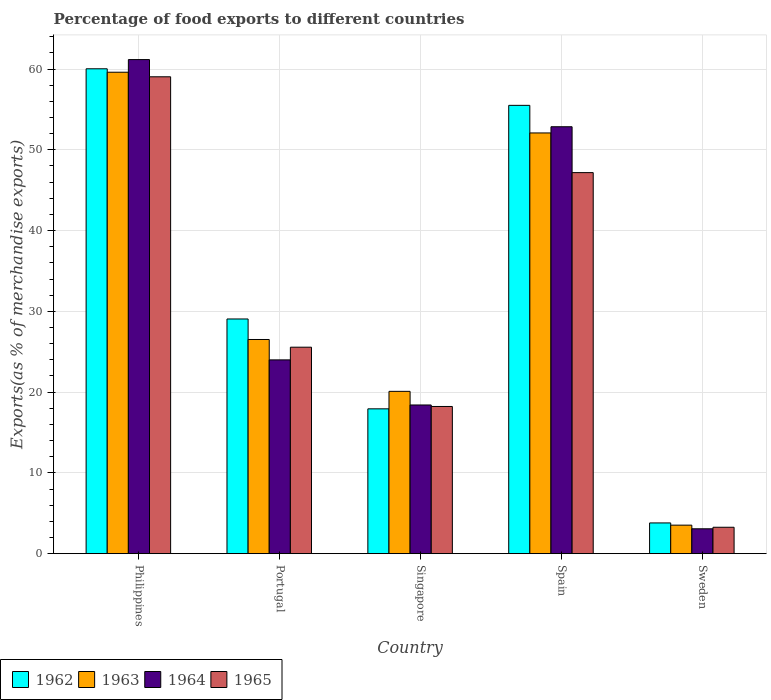Are the number of bars per tick equal to the number of legend labels?
Provide a short and direct response. Yes. How many bars are there on the 5th tick from the left?
Offer a terse response. 4. How many bars are there on the 3rd tick from the right?
Make the answer very short. 4. What is the label of the 4th group of bars from the left?
Give a very brief answer. Spain. In how many cases, is the number of bars for a given country not equal to the number of legend labels?
Make the answer very short. 0. What is the percentage of exports to different countries in 1962 in Sweden?
Your answer should be compact. 3.8. Across all countries, what is the maximum percentage of exports to different countries in 1964?
Make the answer very short. 61.17. Across all countries, what is the minimum percentage of exports to different countries in 1965?
Your answer should be compact. 3.27. What is the total percentage of exports to different countries in 1963 in the graph?
Give a very brief answer. 161.82. What is the difference between the percentage of exports to different countries in 1964 in Spain and that in Sweden?
Make the answer very short. 49.77. What is the difference between the percentage of exports to different countries in 1962 in Singapore and the percentage of exports to different countries in 1963 in Portugal?
Your answer should be very brief. -8.58. What is the average percentage of exports to different countries in 1964 per country?
Ensure brevity in your answer.  31.9. What is the difference between the percentage of exports to different countries of/in 1962 and percentage of exports to different countries of/in 1965 in Singapore?
Make the answer very short. -0.29. In how many countries, is the percentage of exports to different countries in 1964 greater than 34 %?
Ensure brevity in your answer.  2. What is the ratio of the percentage of exports to different countries in 1963 in Philippines to that in Singapore?
Your answer should be very brief. 2.97. Is the percentage of exports to different countries in 1965 in Philippines less than that in Singapore?
Ensure brevity in your answer.  No. Is the difference between the percentage of exports to different countries in 1962 in Singapore and Spain greater than the difference between the percentage of exports to different countries in 1965 in Singapore and Spain?
Offer a terse response. No. What is the difference between the highest and the second highest percentage of exports to different countries in 1963?
Offer a terse response. -33.09. What is the difference between the highest and the lowest percentage of exports to different countries in 1965?
Ensure brevity in your answer.  55.77. What does the 3rd bar from the left in Philippines represents?
Offer a terse response. 1964. What does the 2nd bar from the right in Sweden represents?
Keep it short and to the point. 1964. Is it the case that in every country, the sum of the percentage of exports to different countries in 1964 and percentage of exports to different countries in 1962 is greater than the percentage of exports to different countries in 1965?
Make the answer very short. Yes. How many bars are there?
Ensure brevity in your answer.  20. Are all the bars in the graph horizontal?
Give a very brief answer. No. How many countries are there in the graph?
Your response must be concise. 5. What is the difference between two consecutive major ticks on the Y-axis?
Give a very brief answer. 10. Does the graph contain any zero values?
Offer a very short reply. No. Does the graph contain grids?
Provide a succinct answer. Yes. What is the title of the graph?
Your answer should be very brief. Percentage of food exports to different countries. Does "1981" appear as one of the legend labels in the graph?
Make the answer very short. No. What is the label or title of the X-axis?
Your response must be concise. Country. What is the label or title of the Y-axis?
Ensure brevity in your answer.  Exports(as % of merchandise exports). What is the Exports(as % of merchandise exports) of 1962 in Philippines?
Ensure brevity in your answer.  60.03. What is the Exports(as % of merchandise exports) of 1963 in Philippines?
Your response must be concise. 59.6. What is the Exports(as % of merchandise exports) of 1964 in Philippines?
Keep it short and to the point. 61.17. What is the Exports(as % of merchandise exports) in 1965 in Philippines?
Provide a succinct answer. 59.04. What is the Exports(as % of merchandise exports) in 1962 in Portugal?
Give a very brief answer. 29.05. What is the Exports(as % of merchandise exports) in 1963 in Portugal?
Offer a very short reply. 26.51. What is the Exports(as % of merchandise exports) of 1964 in Portugal?
Provide a short and direct response. 23.99. What is the Exports(as % of merchandise exports) in 1965 in Portugal?
Your answer should be very brief. 25.56. What is the Exports(as % of merchandise exports) of 1962 in Singapore?
Your response must be concise. 17.93. What is the Exports(as % of merchandise exports) in 1963 in Singapore?
Make the answer very short. 20.09. What is the Exports(as % of merchandise exports) in 1964 in Singapore?
Offer a terse response. 18.41. What is the Exports(as % of merchandise exports) of 1965 in Singapore?
Offer a terse response. 18.22. What is the Exports(as % of merchandise exports) in 1962 in Spain?
Your response must be concise. 55.5. What is the Exports(as % of merchandise exports) of 1963 in Spain?
Your answer should be compact. 52.09. What is the Exports(as % of merchandise exports) of 1964 in Spain?
Provide a succinct answer. 52.85. What is the Exports(as % of merchandise exports) of 1965 in Spain?
Provide a short and direct response. 47.17. What is the Exports(as % of merchandise exports) of 1962 in Sweden?
Keep it short and to the point. 3.8. What is the Exports(as % of merchandise exports) in 1963 in Sweden?
Offer a terse response. 3.53. What is the Exports(as % of merchandise exports) in 1964 in Sweden?
Your answer should be very brief. 3.08. What is the Exports(as % of merchandise exports) of 1965 in Sweden?
Keep it short and to the point. 3.27. Across all countries, what is the maximum Exports(as % of merchandise exports) in 1962?
Your answer should be compact. 60.03. Across all countries, what is the maximum Exports(as % of merchandise exports) of 1963?
Offer a terse response. 59.6. Across all countries, what is the maximum Exports(as % of merchandise exports) of 1964?
Your answer should be compact. 61.17. Across all countries, what is the maximum Exports(as % of merchandise exports) in 1965?
Make the answer very short. 59.04. Across all countries, what is the minimum Exports(as % of merchandise exports) of 1962?
Provide a succinct answer. 3.8. Across all countries, what is the minimum Exports(as % of merchandise exports) of 1963?
Give a very brief answer. 3.53. Across all countries, what is the minimum Exports(as % of merchandise exports) of 1964?
Give a very brief answer. 3.08. Across all countries, what is the minimum Exports(as % of merchandise exports) of 1965?
Offer a terse response. 3.27. What is the total Exports(as % of merchandise exports) in 1962 in the graph?
Offer a very short reply. 166.32. What is the total Exports(as % of merchandise exports) of 1963 in the graph?
Give a very brief answer. 161.82. What is the total Exports(as % of merchandise exports) of 1964 in the graph?
Offer a very short reply. 159.49. What is the total Exports(as % of merchandise exports) of 1965 in the graph?
Your answer should be very brief. 153.26. What is the difference between the Exports(as % of merchandise exports) of 1962 in Philippines and that in Portugal?
Give a very brief answer. 30.97. What is the difference between the Exports(as % of merchandise exports) in 1963 in Philippines and that in Portugal?
Provide a succinct answer. 33.09. What is the difference between the Exports(as % of merchandise exports) in 1964 in Philippines and that in Portugal?
Your answer should be compact. 37.18. What is the difference between the Exports(as % of merchandise exports) in 1965 in Philippines and that in Portugal?
Make the answer very short. 33.48. What is the difference between the Exports(as % of merchandise exports) in 1962 in Philippines and that in Singapore?
Give a very brief answer. 42.1. What is the difference between the Exports(as % of merchandise exports) in 1963 in Philippines and that in Singapore?
Your answer should be very brief. 39.51. What is the difference between the Exports(as % of merchandise exports) in 1964 in Philippines and that in Singapore?
Your answer should be compact. 42.76. What is the difference between the Exports(as % of merchandise exports) of 1965 in Philippines and that in Singapore?
Provide a succinct answer. 40.81. What is the difference between the Exports(as % of merchandise exports) of 1962 in Philippines and that in Spain?
Give a very brief answer. 4.53. What is the difference between the Exports(as % of merchandise exports) of 1963 in Philippines and that in Spain?
Your answer should be very brief. 7.52. What is the difference between the Exports(as % of merchandise exports) in 1964 in Philippines and that in Spain?
Offer a terse response. 8.31. What is the difference between the Exports(as % of merchandise exports) in 1965 in Philippines and that in Spain?
Ensure brevity in your answer.  11.86. What is the difference between the Exports(as % of merchandise exports) in 1962 in Philippines and that in Sweden?
Offer a very short reply. 56.22. What is the difference between the Exports(as % of merchandise exports) of 1963 in Philippines and that in Sweden?
Offer a terse response. 56.07. What is the difference between the Exports(as % of merchandise exports) in 1964 in Philippines and that in Sweden?
Provide a short and direct response. 58.09. What is the difference between the Exports(as % of merchandise exports) in 1965 in Philippines and that in Sweden?
Offer a very short reply. 55.77. What is the difference between the Exports(as % of merchandise exports) in 1962 in Portugal and that in Singapore?
Give a very brief answer. 11.12. What is the difference between the Exports(as % of merchandise exports) of 1963 in Portugal and that in Singapore?
Make the answer very short. 6.42. What is the difference between the Exports(as % of merchandise exports) of 1964 in Portugal and that in Singapore?
Your answer should be very brief. 5.58. What is the difference between the Exports(as % of merchandise exports) of 1965 in Portugal and that in Singapore?
Ensure brevity in your answer.  7.34. What is the difference between the Exports(as % of merchandise exports) in 1962 in Portugal and that in Spain?
Your answer should be very brief. -26.45. What is the difference between the Exports(as % of merchandise exports) of 1963 in Portugal and that in Spain?
Your answer should be compact. -25.57. What is the difference between the Exports(as % of merchandise exports) of 1964 in Portugal and that in Spain?
Your response must be concise. -28.86. What is the difference between the Exports(as % of merchandise exports) in 1965 in Portugal and that in Spain?
Keep it short and to the point. -21.61. What is the difference between the Exports(as % of merchandise exports) of 1962 in Portugal and that in Sweden?
Ensure brevity in your answer.  25.25. What is the difference between the Exports(as % of merchandise exports) of 1963 in Portugal and that in Sweden?
Provide a succinct answer. 22.98. What is the difference between the Exports(as % of merchandise exports) of 1964 in Portugal and that in Sweden?
Provide a succinct answer. 20.91. What is the difference between the Exports(as % of merchandise exports) in 1965 in Portugal and that in Sweden?
Provide a short and direct response. 22.29. What is the difference between the Exports(as % of merchandise exports) of 1962 in Singapore and that in Spain?
Ensure brevity in your answer.  -37.57. What is the difference between the Exports(as % of merchandise exports) in 1963 in Singapore and that in Spain?
Your answer should be very brief. -31.99. What is the difference between the Exports(as % of merchandise exports) in 1964 in Singapore and that in Spain?
Provide a short and direct response. -34.45. What is the difference between the Exports(as % of merchandise exports) of 1965 in Singapore and that in Spain?
Your answer should be compact. -28.95. What is the difference between the Exports(as % of merchandise exports) of 1962 in Singapore and that in Sweden?
Provide a succinct answer. 14.13. What is the difference between the Exports(as % of merchandise exports) of 1963 in Singapore and that in Sweden?
Provide a succinct answer. 16.56. What is the difference between the Exports(as % of merchandise exports) of 1964 in Singapore and that in Sweden?
Your answer should be compact. 15.33. What is the difference between the Exports(as % of merchandise exports) in 1965 in Singapore and that in Sweden?
Your response must be concise. 14.95. What is the difference between the Exports(as % of merchandise exports) of 1962 in Spain and that in Sweden?
Ensure brevity in your answer.  51.7. What is the difference between the Exports(as % of merchandise exports) in 1963 in Spain and that in Sweden?
Offer a very short reply. 48.56. What is the difference between the Exports(as % of merchandise exports) in 1964 in Spain and that in Sweden?
Keep it short and to the point. 49.77. What is the difference between the Exports(as % of merchandise exports) in 1965 in Spain and that in Sweden?
Your response must be concise. 43.9. What is the difference between the Exports(as % of merchandise exports) in 1962 in Philippines and the Exports(as % of merchandise exports) in 1963 in Portugal?
Your answer should be very brief. 33.51. What is the difference between the Exports(as % of merchandise exports) in 1962 in Philippines and the Exports(as % of merchandise exports) in 1964 in Portugal?
Offer a terse response. 36.04. What is the difference between the Exports(as % of merchandise exports) in 1962 in Philippines and the Exports(as % of merchandise exports) in 1965 in Portugal?
Ensure brevity in your answer.  34.47. What is the difference between the Exports(as % of merchandise exports) of 1963 in Philippines and the Exports(as % of merchandise exports) of 1964 in Portugal?
Your answer should be compact. 35.61. What is the difference between the Exports(as % of merchandise exports) of 1963 in Philippines and the Exports(as % of merchandise exports) of 1965 in Portugal?
Make the answer very short. 34.04. What is the difference between the Exports(as % of merchandise exports) in 1964 in Philippines and the Exports(as % of merchandise exports) in 1965 in Portugal?
Give a very brief answer. 35.61. What is the difference between the Exports(as % of merchandise exports) in 1962 in Philippines and the Exports(as % of merchandise exports) in 1963 in Singapore?
Your answer should be very brief. 39.93. What is the difference between the Exports(as % of merchandise exports) in 1962 in Philippines and the Exports(as % of merchandise exports) in 1964 in Singapore?
Provide a short and direct response. 41.62. What is the difference between the Exports(as % of merchandise exports) of 1962 in Philippines and the Exports(as % of merchandise exports) of 1965 in Singapore?
Your answer should be very brief. 41.8. What is the difference between the Exports(as % of merchandise exports) in 1963 in Philippines and the Exports(as % of merchandise exports) in 1964 in Singapore?
Your answer should be very brief. 41.2. What is the difference between the Exports(as % of merchandise exports) of 1963 in Philippines and the Exports(as % of merchandise exports) of 1965 in Singapore?
Ensure brevity in your answer.  41.38. What is the difference between the Exports(as % of merchandise exports) in 1964 in Philippines and the Exports(as % of merchandise exports) in 1965 in Singapore?
Provide a succinct answer. 42.95. What is the difference between the Exports(as % of merchandise exports) in 1962 in Philippines and the Exports(as % of merchandise exports) in 1963 in Spain?
Ensure brevity in your answer.  7.94. What is the difference between the Exports(as % of merchandise exports) of 1962 in Philippines and the Exports(as % of merchandise exports) of 1964 in Spain?
Provide a succinct answer. 7.17. What is the difference between the Exports(as % of merchandise exports) in 1962 in Philippines and the Exports(as % of merchandise exports) in 1965 in Spain?
Keep it short and to the point. 12.85. What is the difference between the Exports(as % of merchandise exports) of 1963 in Philippines and the Exports(as % of merchandise exports) of 1964 in Spain?
Make the answer very short. 6.75. What is the difference between the Exports(as % of merchandise exports) of 1963 in Philippines and the Exports(as % of merchandise exports) of 1965 in Spain?
Provide a short and direct response. 12.43. What is the difference between the Exports(as % of merchandise exports) of 1964 in Philippines and the Exports(as % of merchandise exports) of 1965 in Spain?
Keep it short and to the point. 13.99. What is the difference between the Exports(as % of merchandise exports) in 1962 in Philippines and the Exports(as % of merchandise exports) in 1963 in Sweden?
Your answer should be compact. 56.5. What is the difference between the Exports(as % of merchandise exports) in 1962 in Philippines and the Exports(as % of merchandise exports) in 1964 in Sweden?
Offer a very short reply. 56.95. What is the difference between the Exports(as % of merchandise exports) in 1962 in Philippines and the Exports(as % of merchandise exports) in 1965 in Sweden?
Provide a short and direct response. 56.76. What is the difference between the Exports(as % of merchandise exports) of 1963 in Philippines and the Exports(as % of merchandise exports) of 1964 in Sweden?
Offer a very short reply. 56.52. What is the difference between the Exports(as % of merchandise exports) of 1963 in Philippines and the Exports(as % of merchandise exports) of 1965 in Sweden?
Offer a very short reply. 56.33. What is the difference between the Exports(as % of merchandise exports) in 1964 in Philippines and the Exports(as % of merchandise exports) in 1965 in Sweden?
Your response must be concise. 57.9. What is the difference between the Exports(as % of merchandise exports) of 1962 in Portugal and the Exports(as % of merchandise exports) of 1963 in Singapore?
Offer a terse response. 8.96. What is the difference between the Exports(as % of merchandise exports) in 1962 in Portugal and the Exports(as % of merchandise exports) in 1964 in Singapore?
Give a very brief answer. 10.65. What is the difference between the Exports(as % of merchandise exports) in 1962 in Portugal and the Exports(as % of merchandise exports) in 1965 in Singapore?
Your answer should be very brief. 10.83. What is the difference between the Exports(as % of merchandise exports) in 1963 in Portugal and the Exports(as % of merchandise exports) in 1964 in Singapore?
Your response must be concise. 8.11. What is the difference between the Exports(as % of merchandise exports) of 1963 in Portugal and the Exports(as % of merchandise exports) of 1965 in Singapore?
Offer a very short reply. 8.29. What is the difference between the Exports(as % of merchandise exports) in 1964 in Portugal and the Exports(as % of merchandise exports) in 1965 in Singapore?
Ensure brevity in your answer.  5.77. What is the difference between the Exports(as % of merchandise exports) of 1962 in Portugal and the Exports(as % of merchandise exports) of 1963 in Spain?
Keep it short and to the point. -23.03. What is the difference between the Exports(as % of merchandise exports) of 1962 in Portugal and the Exports(as % of merchandise exports) of 1964 in Spain?
Provide a short and direct response. -23.8. What is the difference between the Exports(as % of merchandise exports) in 1962 in Portugal and the Exports(as % of merchandise exports) in 1965 in Spain?
Ensure brevity in your answer.  -18.12. What is the difference between the Exports(as % of merchandise exports) in 1963 in Portugal and the Exports(as % of merchandise exports) in 1964 in Spain?
Keep it short and to the point. -26.34. What is the difference between the Exports(as % of merchandise exports) of 1963 in Portugal and the Exports(as % of merchandise exports) of 1965 in Spain?
Give a very brief answer. -20.66. What is the difference between the Exports(as % of merchandise exports) of 1964 in Portugal and the Exports(as % of merchandise exports) of 1965 in Spain?
Offer a very short reply. -23.18. What is the difference between the Exports(as % of merchandise exports) of 1962 in Portugal and the Exports(as % of merchandise exports) of 1963 in Sweden?
Your response must be concise. 25.53. What is the difference between the Exports(as % of merchandise exports) in 1962 in Portugal and the Exports(as % of merchandise exports) in 1964 in Sweden?
Ensure brevity in your answer.  25.98. What is the difference between the Exports(as % of merchandise exports) of 1962 in Portugal and the Exports(as % of merchandise exports) of 1965 in Sweden?
Your response must be concise. 25.79. What is the difference between the Exports(as % of merchandise exports) of 1963 in Portugal and the Exports(as % of merchandise exports) of 1964 in Sweden?
Offer a terse response. 23.44. What is the difference between the Exports(as % of merchandise exports) of 1963 in Portugal and the Exports(as % of merchandise exports) of 1965 in Sweden?
Your answer should be compact. 23.25. What is the difference between the Exports(as % of merchandise exports) of 1964 in Portugal and the Exports(as % of merchandise exports) of 1965 in Sweden?
Your answer should be very brief. 20.72. What is the difference between the Exports(as % of merchandise exports) in 1962 in Singapore and the Exports(as % of merchandise exports) in 1963 in Spain?
Offer a very short reply. -34.16. What is the difference between the Exports(as % of merchandise exports) in 1962 in Singapore and the Exports(as % of merchandise exports) in 1964 in Spain?
Provide a succinct answer. -34.92. What is the difference between the Exports(as % of merchandise exports) of 1962 in Singapore and the Exports(as % of merchandise exports) of 1965 in Spain?
Keep it short and to the point. -29.24. What is the difference between the Exports(as % of merchandise exports) of 1963 in Singapore and the Exports(as % of merchandise exports) of 1964 in Spain?
Your answer should be very brief. -32.76. What is the difference between the Exports(as % of merchandise exports) in 1963 in Singapore and the Exports(as % of merchandise exports) in 1965 in Spain?
Ensure brevity in your answer.  -27.08. What is the difference between the Exports(as % of merchandise exports) in 1964 in Singapore and the Exports(as % of merchandise exports) in 1965 in Spain?
Your answer should be very brief. -28.77. What is the difference between the Exports(as % of merchandise exports) in 1962 in Singapore and the Exports(as % of merchandise exports) in 1963 in Sweden?
Your response must be concise. 14.4. What is the difference between the Exports(as % of merchandise exports) of 1962 in Singapore and the Exports(as % of merchandise exports) of 1964 in Sweden?
Make the answer very short. 14.85. What is the difference between the Exports(as % of merchandise exports) of 1962 in Singapore and the Exports(as % of merchandise exports) of 1965 in Sweden?
Your answer should be compact. 14.66. What is the difference between the Exports(as % of merchandise exports) of 1963 in Singapore and the Exports(as % of merchandise exports) of 1964 in Sweden?
Your response must be concise. 17.01. What is the difference between the Exports(as % of merchandise exports) of 1963 in Singapore and the Exports(as % of merchandise exports) of 1965 in Sweden?
Make the answer very short. 16.83. What is the difference between the Exports(as % of merchandise exports) in 1964 in Singapore and the Exports(as % of merchandise exports) in 1965 in Sweden?
Ensure brevity in your answer.  15.14. What is the difference between the Exports(as % of merchandise exports) in 1962 in Spain and the Exports(as % of merchandise exports) in 1963 in Sweden?
Ensure brevity in your answer.  51.97. What is the difference between the Exports(as % of merchandise exports) in 1962 in Spain and the Exports(as % of merchandise exports) in 1964 in Sweden?
Offer a very short reply. 52.42. What is the difference between the Exports(as % of merchandise exports) in 1962 in Spain and the Exports(as % of merchandise exports) in 1965 in Sweden?
Make the answer very short. 52.23. What is the difference between the Exports(as % of merchandise exports) in 1963 in Spain and the Exports(as % of merchandise exports) in 1964 in Sweden?
Your response must be concise. 49.01. What is the difference between the Exports(as % of merchandise exports) in 1963 in Spain and the Exports(as % of merchandise exports) in 1965 in Sweden?
Your response must be concise. 48.82. What is the difference between the Exports(as % of merchandise exports) of 1964 in Spain and the Exports(as % of merchandise exports) of 1965 in Sweden?
Ensure brevity in your answer.  49.58. What is the average Exports(as % of merchandise exports) of 1962 per country?
Ensure brevity in your answer.  33.26. What is the average Exports(as % of merchandise exports) of 1963 per country?
Make the answer very short. 32.36. What is the average Exports(as % of merchandise exports) of 1964 per country?
Offer a terse response. 31.9. What is the average Exports(as % of merchandise exports) in 1965 per country?
Provide a succinct answer. 30.65. What is the difference between the Exports(as % of merchandise exports) of 1962 and Exports(as % of merchandise exports) of 1963 in Philippines?
Keep it short and to the point. 0.42. What is the difference between the Exports(as % of merchandise exports) in 1962 and Exports(as % of merchandise exports) in 1964 in Philippines?
Your response must be concise. -1.14. What is the difference between the Exports(as % of merchandise exports) in 1962 and Exports(as % of merchandise exports) in 1965 in Philippines?
Your answer should be compact. 0.99. What is the difference between the Exports(as % of merchandise exports) in 1963 and Exports(as % of merchandise exports) in 1964 in Philippines?
Provide a succinct answer. -1.57. What is the difference between the Exports(as % of merchandise exports) in 1963 and Exports(as % of merchandise exports) in 1965 in Philippines?
Offer a terse response. 0.57. What is the difference between the Exports(as % of merchandise exports) of 1964 and Exports(as % of merchandise exports) of 1965 in Philippines?
Your answer should be compact. 2.13. What is the difference between the Exports(as % of merchandise exports) of 1962 and Exports(as % of merchandise exports) of 1963 in Portugal?
Keep it short and to the point. 2.54. What is the difference between the Exports(as % of merchandise exports) of 1962 and Exports(as % of merchandise exports) of 1964 in Portugal?
Provide a succinct answer. 5.06. What is the difference between the Exports(as % of merchandise exports) of 1962 and Exports(as % of merchandise exports) of 1965 in Portugal?
Keep it short and to the point. 3.49. What is the difference between the Exports(as % of merchandise exports) of 1963 and Exports(as % of merchandise exports) of 1964 in Portugal?
Make the answer very short. 2.52. What is the difference between the Exports(as % of merchandise exports) in 1963 and Exports(as % of merchandise exports) in 1965 in Portugal?
Offer a terse response. 0.95. What is the difference between the Exports(as % of merchandise exports) of 1964 and Exports(as % of merchandise exports) of 1965 in Portugal?
Provide a short and direct response. -1.57. What is the difference between the Exports(as % of merchandise exports) of 1962 and Exports(as % of merchandise exports) of 1963 in Singapore?
Make the answer very short. -2.16. What is the difference between the Exports(as % of merchandise exports) of 1962 and Exports(as % of merchandise exports) of 1964 in Singapore?
Give a very brief answer. -0.48. What is the difference between the Exports(as % of merchandise exports) of 1962 and Exports(as % of merchandise exports) of 1965 in Singapore?
Offer a very short reply. -0.29. What is the difference between the Exports(as % of merchandise exports) in 1963 and Exports(as % of merchandise exports) in 1964 in Singapore?
Ensure brevity in your answer.  1.69. What is the difference between the Exports(as % of merchandise exports) of 1963 and Exports(as % of merchandise exports) of 1965 in Singapore?
Your answer should be compact. 1.87. What is the difference between the Exports(as % of merchandise exports) in 1964 and Exports(as % of merchandise exports) in 1965 in Singapore?
Provide a short and direct response. 0.18. What is the difference between the Exports(as % of merchandise exports) of 1962 and Exports(as % of merchandise exports) of 1963 in Spain?
Your answer should be very brief. 3.42. What is the difference between the Exports(as % of merchandise exports) in 1962 and Exports(as % of merchandise exports) in 1964 in Spain?
Give a very brief answer. 2.65. What is the difference between the Exports(as % of merchandise exports) of 1962 and Exports(as % of merchandise exports) of 1965 in Spain?
Provide a short and direct response. 8.33. What is the difference between the Exports(as % of merchandise exports) in 1963 and Exports(as % of merchandise exports) in 1964 in Spain?
Your answer should be compact. -0.77. What is the difference between the Exports(as % of merchandise exports) in 1963 and Exports(as % of merchandise exports) in 1965 in Spain?
Give a very brief answer. 4.91. What is the difference between the Exports(as % of merchandise exports) of 1964 and Exports(as % of merchandise exports) of 1965 in Spain?
Offer a very short reply. 5.68. What is the difference between the Exports(as % of merchandise exports) in 1962 and Exports(as % of merchandise exports) in 1963 in Sweden?
Offer a terse response. 0.28. What is the difference between the Exports(as % of merchandise exports) of 1962 and Exports(as % of merchandise exports) of 1964 in Sweden?
Keep it short and to the point. 0.73. What is the difference between the Exports(as % of merchandise exports) of 1962 and Exports(as % of merchandise exports) of 1965 in Sweden?
Your answer should be compact. 0.54. What is the difference between the Exports(as % of merchandise exports) in 1963 and Exports(as % of merchandise exports) in 1964 in Sweden?
Your response must be concise. 0.45. What is the difference between the Exports(as % of merchandise exports) of 1963 and Exports(as % of merchandise exports) of 1965 in Sweden?
Offer a terse response. 0.26. What is the difference between the Exports(as % of merchandise exports) in 1964 and Exports(as % of merchandise exports) in 1965 in Sweden?
Give a very brief answer. -0.19. What is the ratio of the Exports(as % of merchandise exports) in 1962 in Philippines to that in Portugal?
Your answer should be very brief. 2.07. What is the ratio of the Exports(as % of merchandise exports) in 1963 in Philippines to that in Portugal?
Offer a terse response. 2.25. What is the ratio of the Exports(as % of merchandise exports) of 1964 in Philippines to that in Portugal?
Provide a succinct answer. 2.55. What is the ratio of the Exports(as % of merchandise exports) in 1965 in Philippines to that in Portugal?
Your answer should be very brief. 2.31. What is the ratio of the Exports(as % of merchandise exports) in 1962 in Philippines to that in Singapore?
Keep it short and to the point. 3.35. What is the ratio of the Exports(as % of merchandise exports) of 1963 in Philippines to that in Singapore?
Offer a terse response. 2.97. What is the ratio of the Exports(as % of merchandise exports) in 1964 in Philippines to that in Singapore?
Your answer should be very brief. 3.32. What is the ratio of the Exports(as % of merchandise exports) of 1965 in Philippines to that in Singapore?
Make the answer very short. 3.24. What is the ratio of the Exports(as % of merchandise exports) in 1962 in Philippines to that in Spain?
Offer a very short reply. 1.08. What is the ratio of the Exports(as % of merchandise exports) in 1963 in Philippines to that in Spain?
Make the answer very short. 1.14. What is the ratio of the Exports(as % of merchandise exports) in 1964 in Philippines to that in Spain?
Your response must be concise. 1.16. What is the ratio of the Exports(as % of merchandise exports) of 1965 in Philippines to that in Spain?
Your answer should be very brief. 1.25. What is the ratio of the Exports(as % of merchandise exports) in 1962 in Philippines to that in Sweden?
Keep it short and to the point. 15.78. What is the ratio of the Exports(as % of merchandise exports) of 1963 in Philippines to that in Sweden?
Offer a very short reply. 16.89. What is the ratio of the Exports(as % of merchandise exports) in 1964 in Philippines to that in Sweden?
Ensure brevity in your answer.  19.87. What is the ratio of the Exports(as % of merchandise exports) of 1965 in Philippines to that in Sweden?
Your response must be concise. 18.07. What is the ratio of the Exports(as % of merchandise exports) in 1962 in Portugal to that in Singapore?
Provide a short and direct response. 1.62. What is the ratio of the Exports(as % of merchandise exports) in 1963 in Portugal to that in Singapore?
Provide a short and direct response. 1.32. What is the ratio of the Exports(as % of merchandise exports) in 1964 in Portugal to that in Singapore?
Give a very brief answer. 1.3. What is the ratio of the Exports(as % of merchandise exports) in 1965 in Portugal to that in Singapore?
Your answer should be compact. 1.4. What is the ratio of the Exports(as % of merchandise exports) of 1962 in Portugal to that in Spain?
Keep it short and to the point. 0.52. What is the ratio of the Exports(as % of merchandise exports) of 1963 in Portugal to that in Spain?
Make the answer very short. 0.51. What is the ratio of the Exports(as % of merchandise exports) in 1964 in Portugal to that in Spain?
Provide a short and direct response. 0.45. What is the ratio of the Exports(as % of merchandise exports) of 1965 in Portugal to that in Spain?
Provide a succinct answer. 0.54. What is the ratio of the Exports(as % of merchandise exports) in 1962 in Portugal to that in Sweden?
Provide a short and direct response. 7.64. What is the ratio of the Exports(as % of merchandise exports) in 1963 in Portugal to that in Sweden?
Offer a very short reply. 7.51. What is the ratio of the Exports(as % of merchandise exports) of 1964 in Portugal to that in Sweden?
Give a very brief answer. 7.79. What is the ratio of the Exports(as % of merchandise exports) of 1965 in Portugal to that in Sweden?
Make the answer very short. 7.82. What is the ratio of the Exports(as % of merchandise exports) of 1962 in Singapore to that in Spain?
Your response must be concise. 0.32. What is the ratio of the Exports(as % of merchandise exports) in 1963 in Singapore to that in Spain?
Your answer should be compact. 0.39. What is the ratio of the Exports(as % of merchandise exports) in 1964 in Singapore to that in Spain?
Ensure brevity in your answer.  0.35. What is the ratio of the Exports(as % of merchandise exports) in 1965 in Singapore to that in Spain?
Make the answer very short. 0.39. What is the ratio of the Exports(as % of merchandise exports) in 1962 in Singapore to that in Sweden?
Your answer should be compact. 4.71. What is the ratio of the Exports(as % of merchandise exports) in 1963 in Singapore to that in Sweden?
Keep it short and to the point. 5.69. What is the ratio of the Exports(as % of merchandise exports) in 1964 in Singapore to that in Sweden?
Provide a short and direct response. 5.98. What is the ratio of the Exports(as % of merchandise exports) in 1965 in Singapore to that in Sweden?
Offer a terse response. 5.58. What is the ratio of the Exports(as % of merchandise exports) in 1962 in Spain to that in Sweden?
Give a very brief answer. 14.59. What is the ratio of the Exports(as % of merchandise exports) in 1963 in Spain to that in Sweden?
Your answer should be compact. 14.76. What is the ratio of the Exports(as % of merchandise exports) in 1964 in Spain to that in Sweden?
Provide a short and direct response. 17.17. What is the ratio of the Exports(as % of merchandise exports) in 1965 in Spain to that in Sweden?
Provide a succinct answer. 14.44. What is the difference between the highest and the second highest Exports(as % of merchandise exports) of 1962?
Offer a terse response. 4.53. What is the difference between the highest and the second highest Exports(as % of merchandise exports) of 1963?
Make the answer very short. 7.52. What is the difference between the highest and the second highest Exports(as % of merchandise exports) of 1964?
Provide a short and direct response. 8.31. What is the difference between the highest and the second highest Exports(as % of merchandise exports) of 1965?
Your answer should be compact. 11.86. What is the difference between the highest and the lowest Exports(as % of merchandise exports) in 1962?
Keep it short and to the point. 56.22. What is the difference between the highest and the lowest Exports(as % of merchandise exports) of 1963?
Your answer should be very brief. 56.07. What is the difference between the highest and the lowest Exports(as % of merchandise exports) in 1964?
Provide a succinct answer. 58.09. What is the difference between the highest and the lowest Exports(as % of merchandise exports) in 1965?
Make the answer very short. 55.77. 